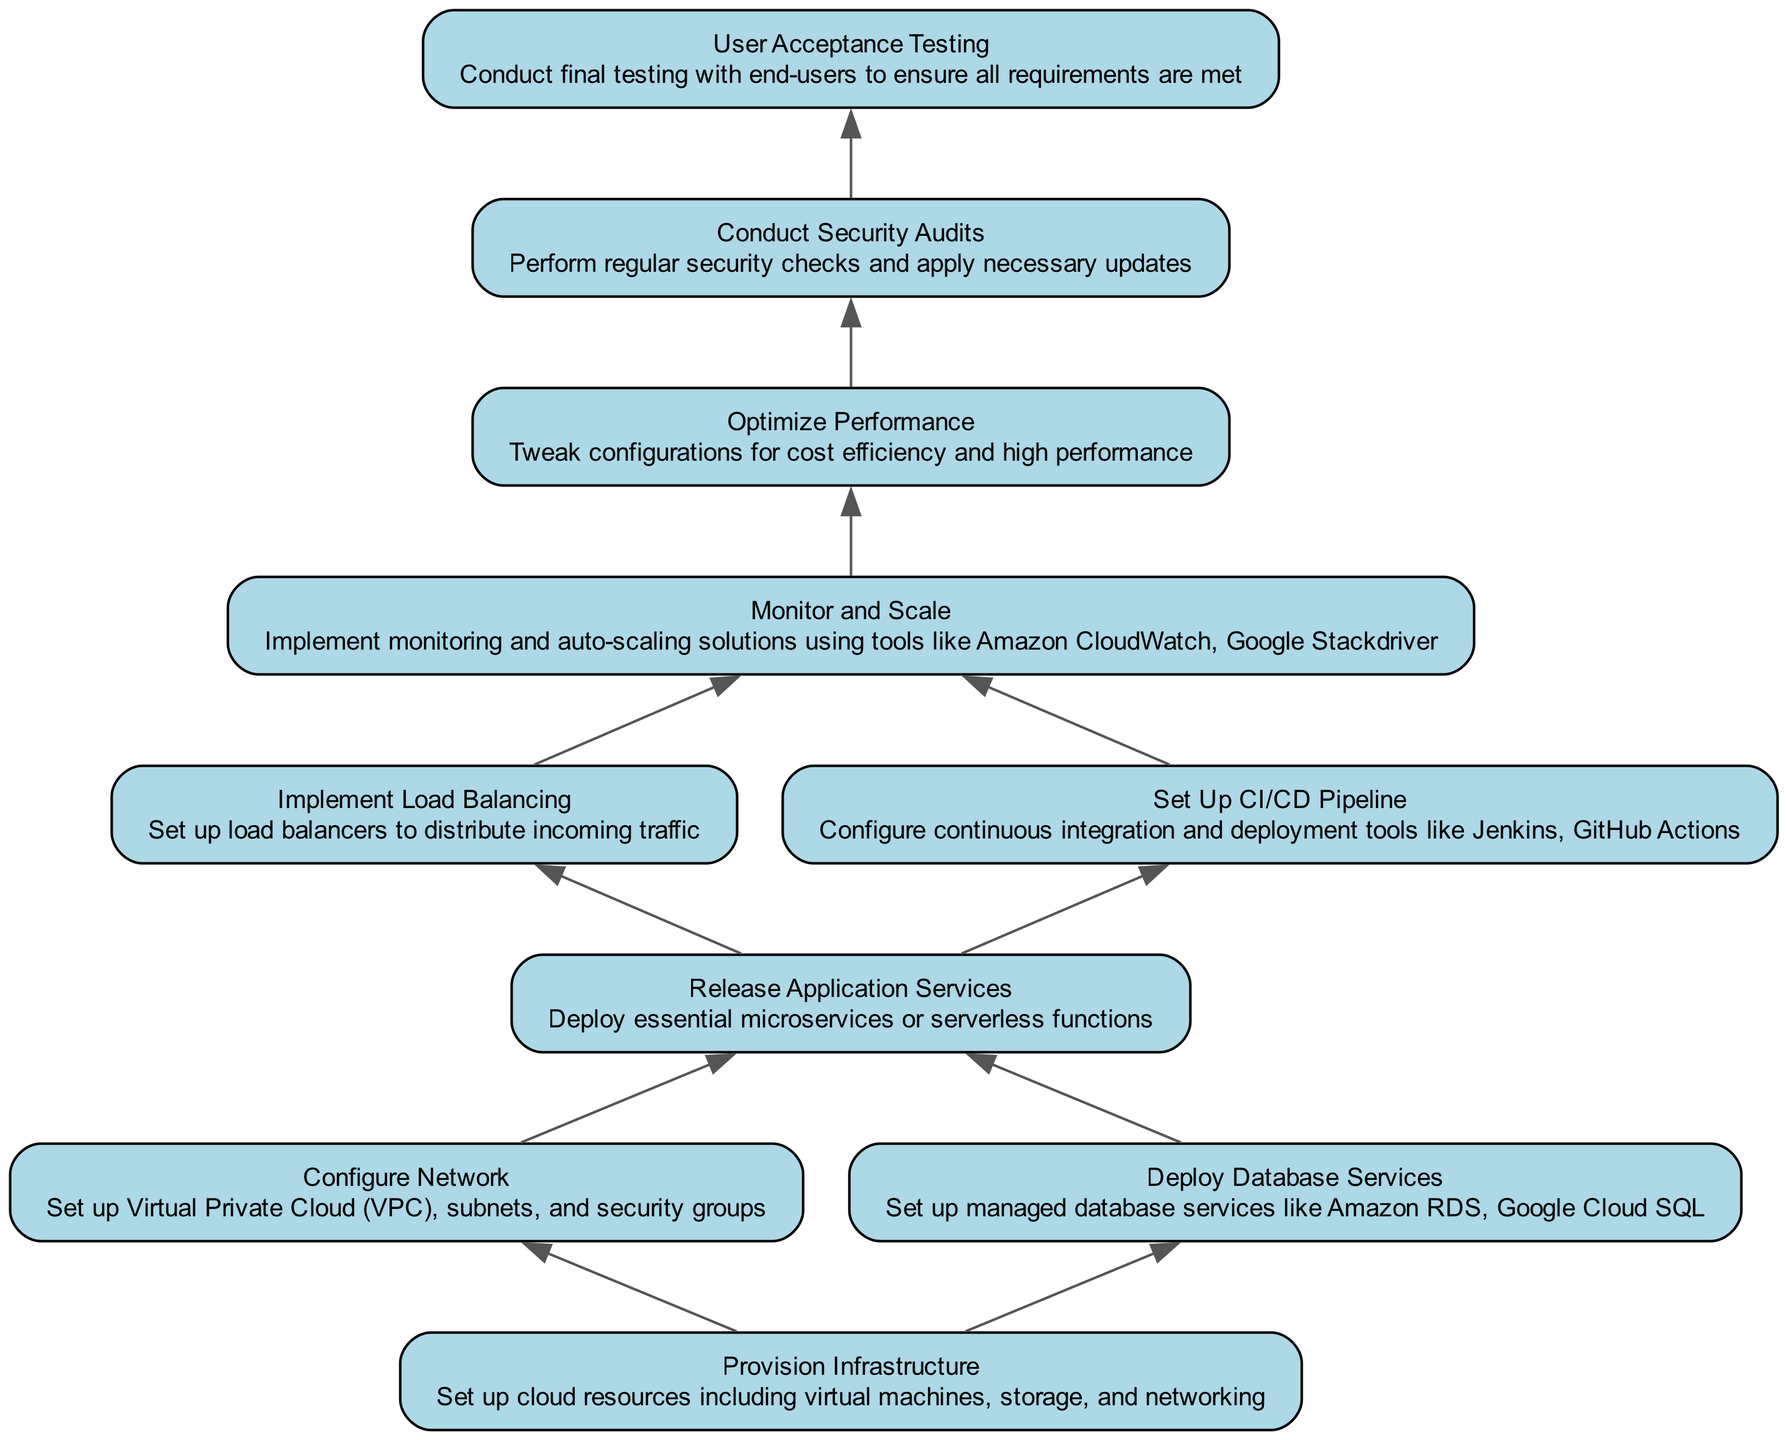What is the first node in the diagram? The first node in the diagram is "Provision Infrastructure" which has no dependencies and thus starts the flow.
Answer: Provision Infrastructure How many total nodes are present in the diagram? There are 10 nodes listed in the diagram, each representing various steps in the cloud-based architecture design process.
Answer: 10 Which node does "User Acceptance Testing" depend on? "User Acceptance Testing" depends on "Conduct Security Audits," meaning it cannot start until the security audits are completed.
Answer: Conduct Security Audits What is the last node in the flow? The last node in the flow is "User Acceptance Testing," which indicates it's the final step before the implementation can be considered complete.
Answer: User Acceptance Testing Which nodes depend on "Release Application Services"? Two nodes depend on "Release Application Services": "Implement Load Balancing" and "Set Up CI/CD Pipeline," both of which cannot be initiated until application services are released.
Answer: Implement Load Balancing, Set Up CI/CD Pipeline What process follows after "Monitor and Scale"? The process that follows "Monitor and Scale" is "Optimize Performance," indicating that upon monitoring, adjustments for performance optimization take place.
Answer: Optimize Performance How many dependencies does "Configure Network" have? "Configure Network" has one dependency, which is "Provision Infrastructure," meaning it is dependent on the completion of that initial task before starting.
Answer: 1 What are the two final steps in the architecture design? The final steps in the architecture design are "Conduct Security Audits" followed by "User Acceptance Testing," ensuring security checks and user validation are last priorities.
Answer: Conduct Security Audits, User Acceptance Testing What is the primary purpose of the node "Deploy Database Services"? The primary purpose of "Deploy Database Services" is to set up managed database services, which are crucial for data handling in the overall architecture.
Answer: Set up managed database services Which two nodes need to be completed before "Monitor and Scale" can start? "Implement Load Balancing" and "Set Up CI/CD Pipeline" need to be completed before "Monitor and Scale" can commence, as they are prerequisites for monitoring performance effectively.
Answer: Implement Load Balancing, Set Up CI/CD Pipeline 